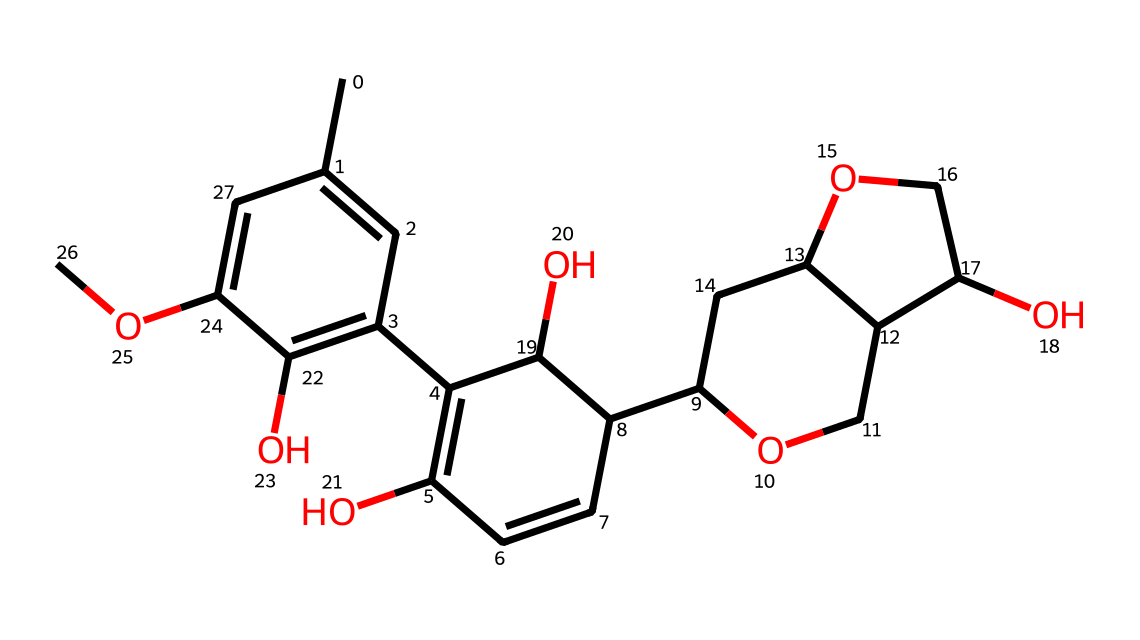What is the number of carbon atoms in this chemical? To determine the number of carbon atoms, we can look for the carbon symbols (C) in the SMILES representation. Counting all the 'C' notations gives us a total of 15 carbon atoms.
Answer: 15 How many hydroxyl (–OH) groups are present in the chemical structure? Hydroxyl groups are represented by the presence of an oxygen (O) immediately followed by a hydrogen (H) in the structure. In the SMILES, we can identify three –OH groups.
Answer: 3 Which type of chemical functional group is prominently featured in this structure? The presence of multiple –OH groups indicates that this compound is an alcohol, specifically a polyphenolic alcohol due to its complex structure.
Answer: alcohol What is the degree of unsaturation in the chemical structure? The degree of unsaturation can be calculated by observing the number of rings and double bonds present. In this SMILES representation, there are three double bonds and one ring, leading to a degree of unsaturation of 4.
Answer: 4 Identify the largest substituent group attached to the aromatic ring. The largest substituent on the aromatic ring is the aliphatic chain ending with the ether link, which is a significant feature of this chemical structure.
Answer: aliphatic chain Does this chemical suggest a specific biological function in plant cell walls? The presence of lignin in the structure suggests its role as a support material in plant cell walls, indicating its importance in providing structural integrity.
Answer: support material 